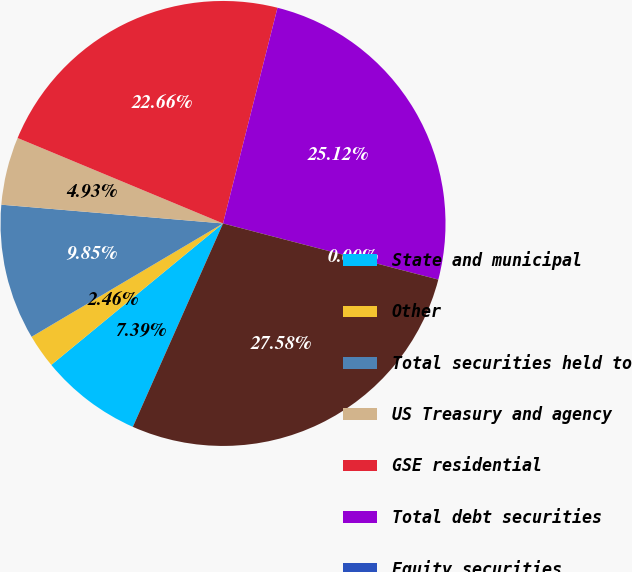<chart> <loc_0><loc_0><loc_500><loc_500><pie_chart><fcel>State and municipal<fcel>Other<fcel>Total securities held to<fcel>US Treasury and agency<fcel>GSE residential<fcel>Total debt securities<fcel>Equity securities<fcel>Total securities available for<nl><fcel>7.39%<fcel>2.46%<fcel>9.85%<fcel>4.93%<fcel>22.66%<fcel>25.12%<fcel>0.0%<fcel>27.58%<nl></chart> 